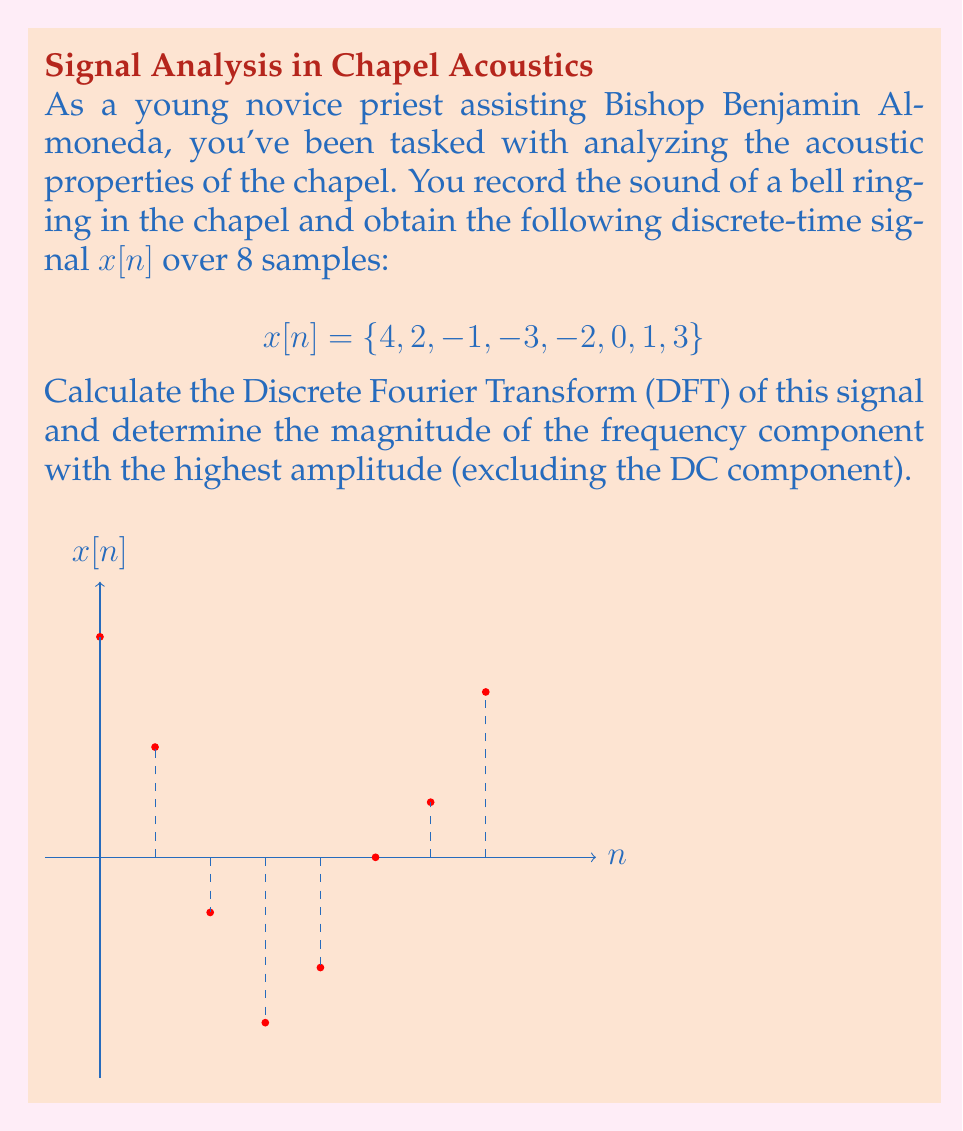What is the answer to this math problem? To solve this problem, we'll follow these steps:

1) The Discrete Fourier Transform (DFT) of a signal $x[n]$ of length N is given by:

   $$X[k] = \sum_{n=0}^{N-1} x[n] e^{-j2\pi kn/N}$$

   where $k = 0, 1, ..., N-1$

2) In this case, N = 8. We need to calculate $X[k]$ for $k = 0, 1, ..., 7$

3) Let's calculate a few terms:

   For $k = 0$ (DC component):
   $$X[0] = 4 + 2 - 1 - 3 - 2 + 0 + 1 + 3 = 4$$

   For $k = 1$:
   $$X[1] = 4e^{0} + 2e^{-j\pi/4} - 1e^{-j\pi/2} - 3e^{-j3\pi/4} - 2e^{-j\pi} + 0e^{-j5\pi/4} + 1e^{-j3\pi/2} + 3e^{-j7\pi/4}$$

4) Calculating all terms (which would typically be done with a computer):

   $$X[0] = 4$$
   $$X[1] = 4.83 - 5.83i$$
   $$X[2] = -2 - 2i$$
   $$X[3] = -0.83 + 1.83i$$
   $$X[4] = 4$$
   $$X[5] = -0.83 - 1.83i$$
   $$X[6] = -2 + 2i$$
   $$X[7] = 4.83 + 5.83i$$

5) To find the magnitude of each component, we calculate $|X[k]| = \sqrt{\text{Re}(X[k])^2 + \text{Im}(X[k])^2}$:

   $$|X[0]| = 4$$
   $$|X[1]| = |X[7]| = \sqrt{4.83^2 + 5.83^2} \approx 7.57$$
   $$|X[2]| = |X[6]| = \sqrt{(-2)^2 + (-2)^2} \approx 2.83$$
   $$|X[3]| = |X[5]| = \sqrt{(-0.83)^2 + 1.83^2} \approx 2$$
   $$|X[4]| = 4$$

6) The highest magnitude, excluding the DC component (k=0), is approximately 7.57, corresponding to k=1 and k=7.
Answer: 7.57 